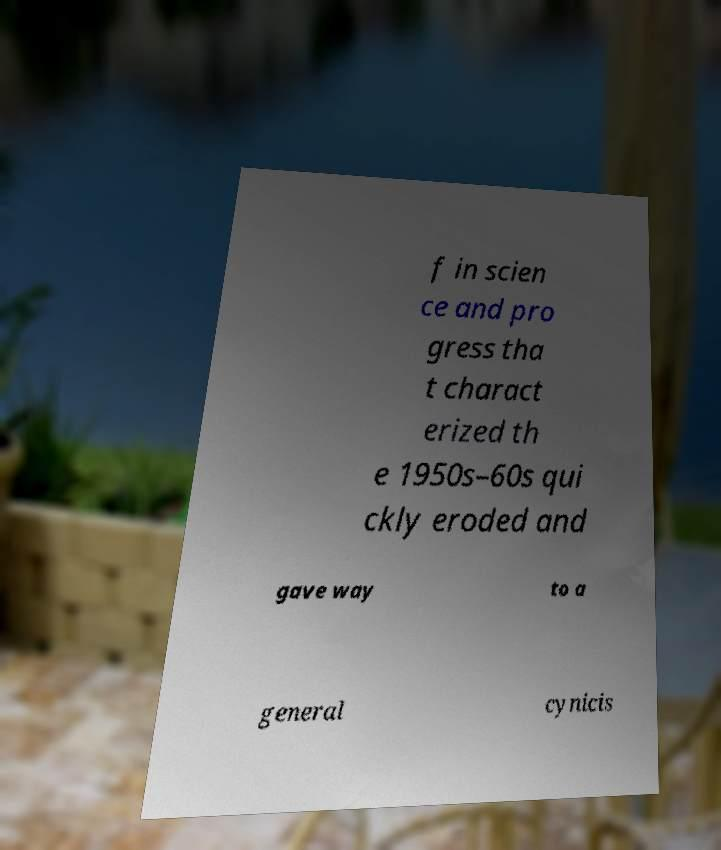Could you assist in decoding the text presented in this image and type it out clearly? f in scien ce and pro gress tha t charact erized th e 1950s–60s qui ckly eroded and gave way to a general cynicis 